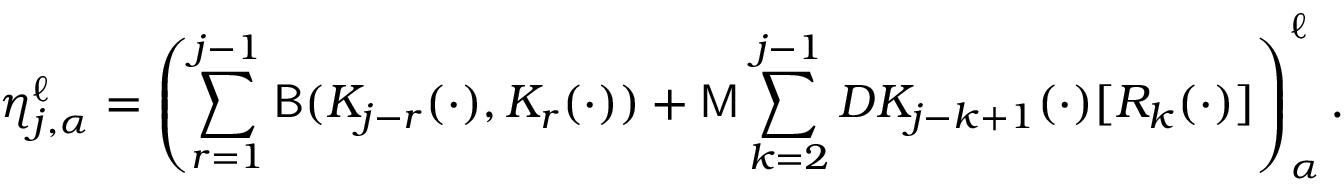Convert formula to latex. <formula><loc_0><loc_0><loc_500><loc_500>\eta _ { j , \alpha } ^ { \ell } = \left ( \sum _ { r = 1 } ^ { j - 1 } B ( K _ { j - r } ( \cdot ) , K _ { r } ( \cdot ) ) + M \sum _ { k = 2 } ^ { j - 1 } D K _ { j - k + 1 } ( \cdot ) [ R _ { k } ( \cdot ) ] \right ) _ { \alpha } ^ { \ell } .</formula> 